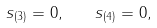<formula> <loc_0><loc_0><loc_500><loc_500>s _ { ( 3 ) } = 0 , \quad s _ { ( 4 ) } = 0 ,</formula> 